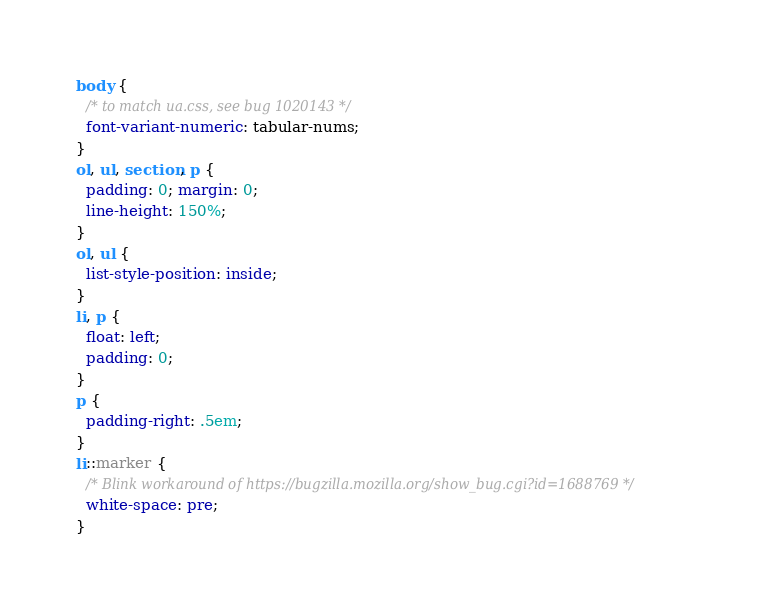<code> <loc_0><loc_0><loc_500><loc_500><_CSS_>body {
  /* to match ua.css, see bug 1020143 */
  font-variant-numeric: tabular-nums;
}
ol, ul, section, p {
  padding: 0; margin: 0;
  line-height: 150%;
}
ol, ul {
  list-style-position: inside;
}
li, p {
  float: left;
  padding: 0;
}
p {
  padding-right: .5em;
}
li::marker {
  /* Blink workaround of https://bugzilla.mozilla.org/show_bug.cgi?id=1688769 */
  white-space: pre;
}
</code> 